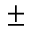Convert formula to latex. <formula><loc_0><loc_0><loc_500><loc_500>\pm</formula> 